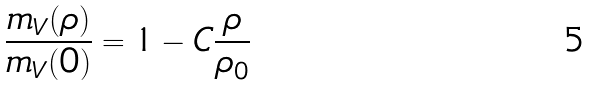Convert formula to latex. <formula><loc_0><loc_0><loc_500><loc_500>\frac { m _ { V } ( \rho ) } { m _ { V } ( 0 ) } = 1 - C \frac { \rho } { \rho _ { 0 } }</formula> 